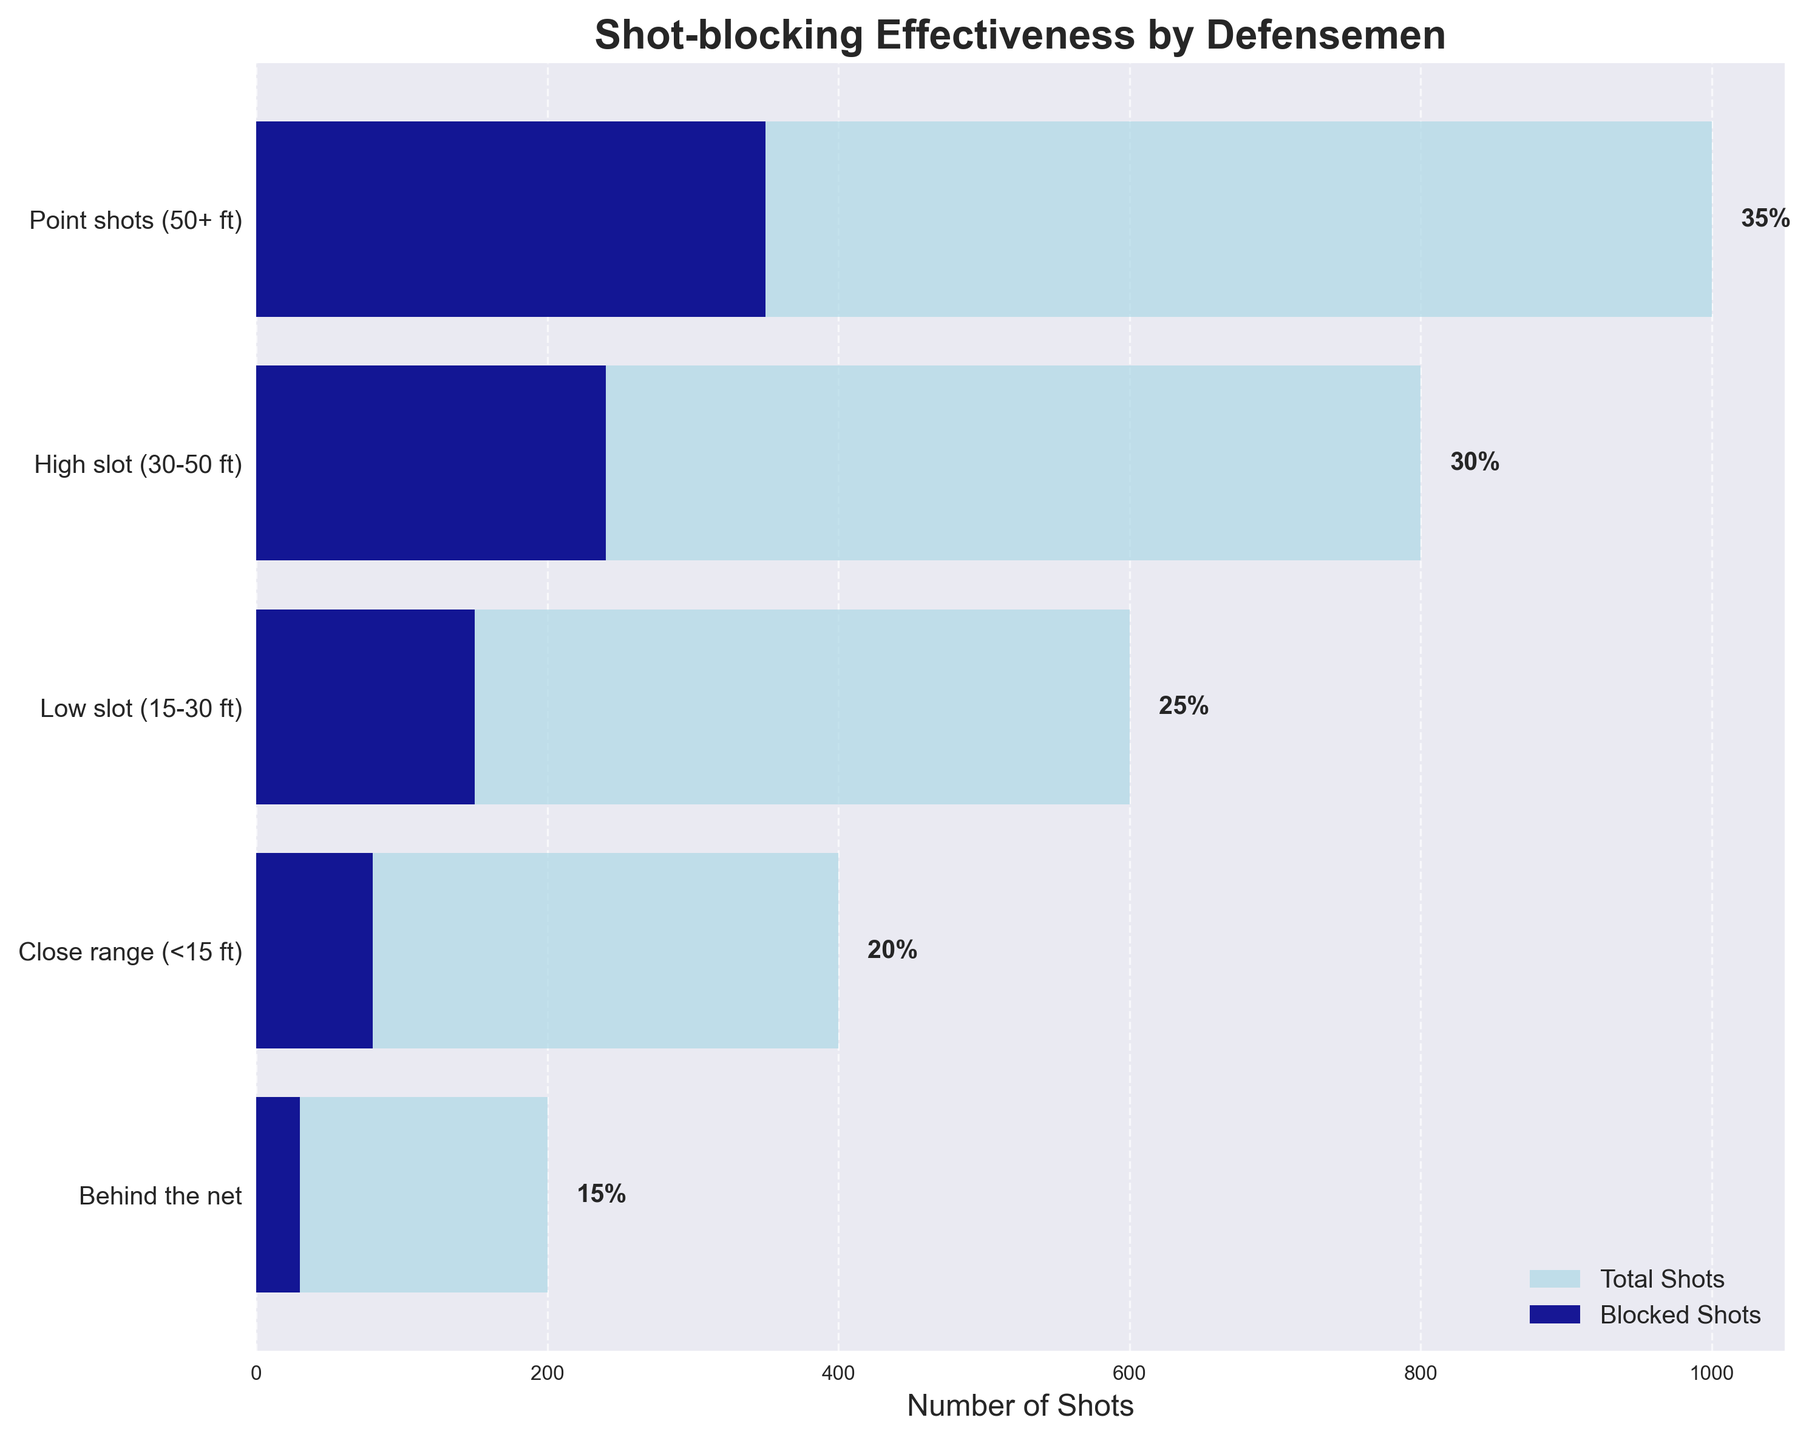What's the title of the chart? The title is usually displayed at the top of the chart. In this case, it reads "Shot-blocking Effectiveness by Defensemen" which gives an overview of what the chart is about.
Answer: Shot-blocking Effectiveness by Defensemen Which shooting angle or distance has the highest total number of shots? The highest total number of shots can be determined by looking at the length of the light blue bars across different stages. The "Point shots (50+ ft)" stage has the longest light blue bar, indicating it has the highest total number of shots.
Answer: Point shots (50+ ft) How many shots were taken from the low slot (15-30 ft)? The total number of shots for each stage is displayed next to the light blue bars. For the low slot (15-30 ft) stage, the total number of shots is shown as 600.
Answer: 600 What's the effectiveness percentage for high slot (30-50 ft) shots? The effectiveness percentage is indicated by the text next to each bar group. For the high slot (30-50 ft) stage, it reads 30%.
Answer: 30% How does the number of blocked shots from close range (<15 ft) compare to those from behind the net? By comparing the lengths of the dark blue bars, we can see that the number of blocked shots from close range (<15 ft) is longer than the bar for blocked shots from behind the net. Specifically, it's 80 compared to 30.
Answer: More What's the overall trend in shot-blocking effectiveness as the shooting distance decreases? The effectiveness percentages are displayed next to each stage. We observe that shot-blocking effectiveness decreases as the shooting distance decreases, moving from 35% for point shots to 15% for shots from behind the net.
Answer: Decreases How many more total shots are there from the point shots (50+ ft) stage compared to the close range (<15 ft) stage? The total shots for the point shots stage are 1000, and for the close range stage are 400. Subtracting these gives 1000 - 400 = 600 more shots from the point shots stage.
Answer: 600 What percentage of shots from the low slot (15-30 ft) are blocked? The total and blocked shots are 600 and 150 respectively for the low slot. The percentage is calculated as (150 / 600) * 100 which equals 25%.
Answer: 25% Which stage has the lowest shot-blocking effectiveness? Shot-blocking effectiveness is displayed alongside each bar group. The stage with the lowest percentage is 'Behind the net' with an effectiveness of 15%.
Answer: Behind the net Compare the number of blocked shots from the high slot (30-50 ft) to the total number of shots from behind the net. By looking at the dark blue bar for blocked shots from the high slot and the light blue bar for total shots behind the net, we see that the numbers are 240 and 200 respectively. So, the blocked shots from the high slot are higher.
Answer: Higher 